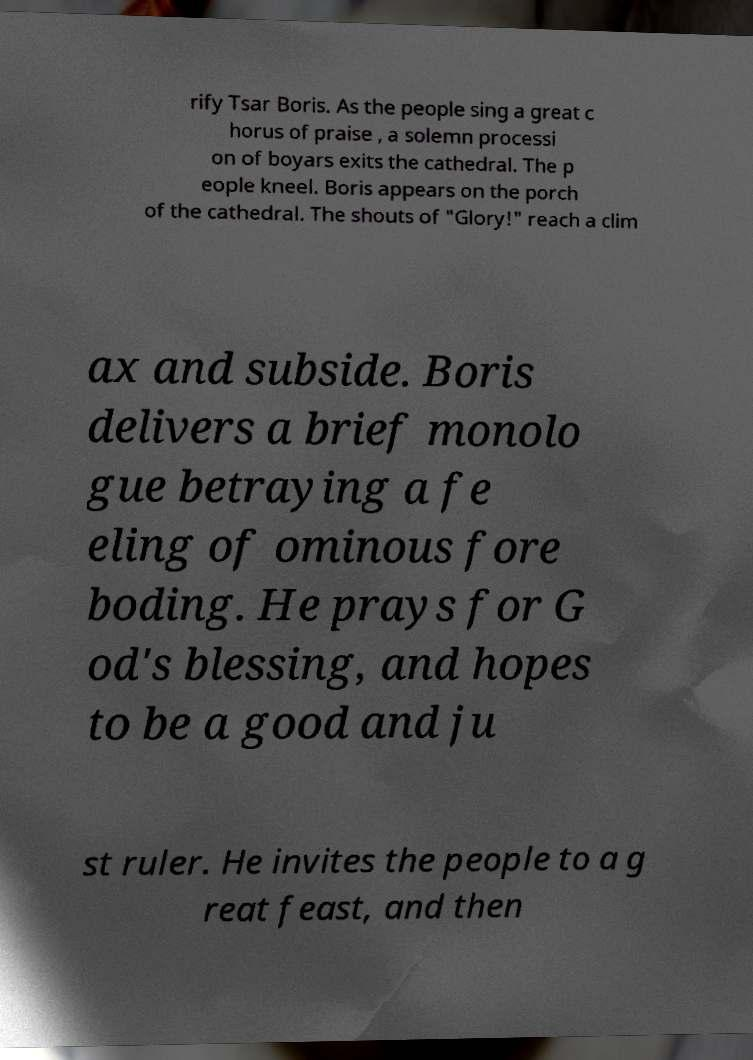Could you assist in decoding the text presented in this image and type it out clearly? rify Tsar Boris. As the people sing a great c horus of praise , a solemn processi on of boyars exits the cathedral. The p eople kneel. Boris appears on the porch of the cathedral. The shouts of "Glory!" reach a clim ax and subside. Boris delivers a brief monolo gue betraying a fe eling of ominous fore boding. He prays for G od's blessing, and hopes to be a good and ju st ruler. He invites the people to a g reat feast, and then 